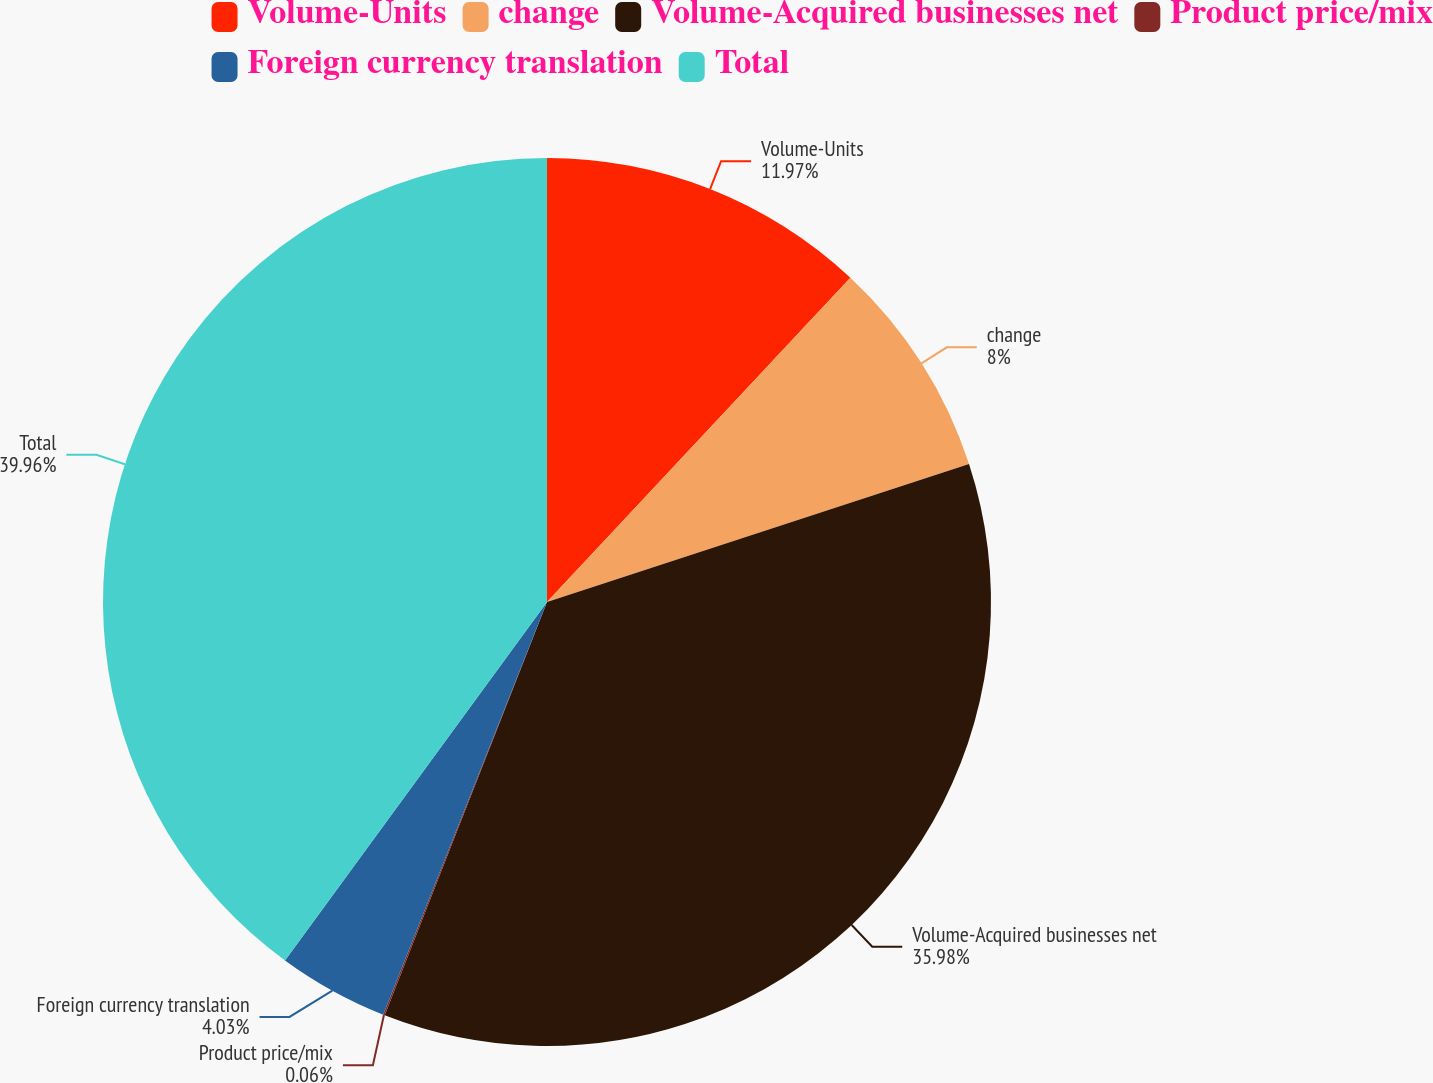<chart> <loc_0><loc_0><loc_500><loc_500><pie_chart><fcel>Volume-Units<fcel>change<fcel>Volume-Acquired businesses net<fcel>Product price/mix<fcel>Foreign currency translation<fcel>Total<nl><fcel>11.97%<fcel>8.0%<fcel>35.98%<fcel>0.06%<fcel>4.03%<fcel>39.95%<nl></chart> 